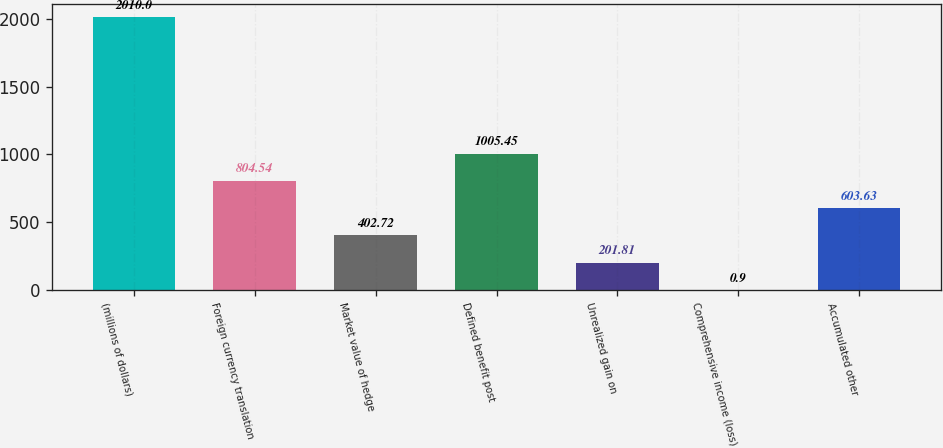<chart> <loc_0><loc_0><loc_500><loc_500><bar_chart><fcel>(millions of dollars)<fcel>Foreign currency translation<fcel>Market value of hedge<fcel>Defined benefit post<fcel>Unrealized gain on<fcel>Comprehensive income (loss)<fcel>Accumulated other<nl><fcel>2010<fcel>804.54<fcel>402.72<fcel>1005.45<fcel>201.81<fcel>0.9<fcel>603.63<nl></chart> 